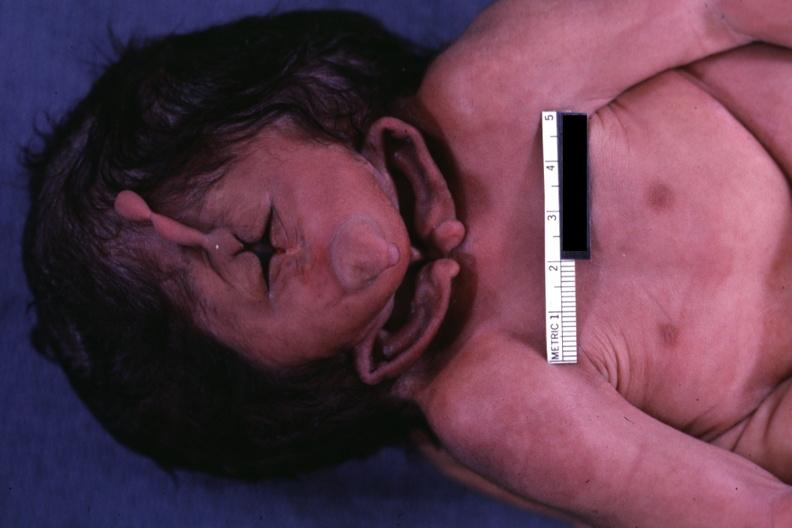what is present?
Answer the question using a single word or phrase. Conjoined twins 